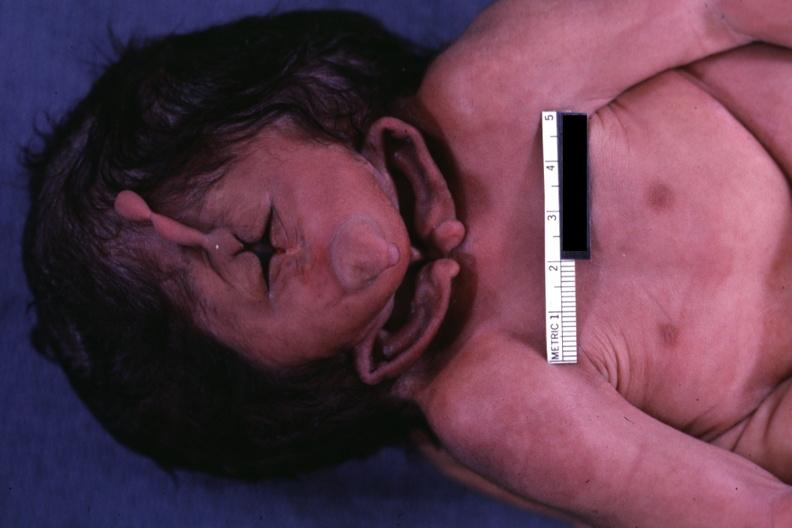what is present?
Answer the question using a single word or phrase. Conjoined twins 